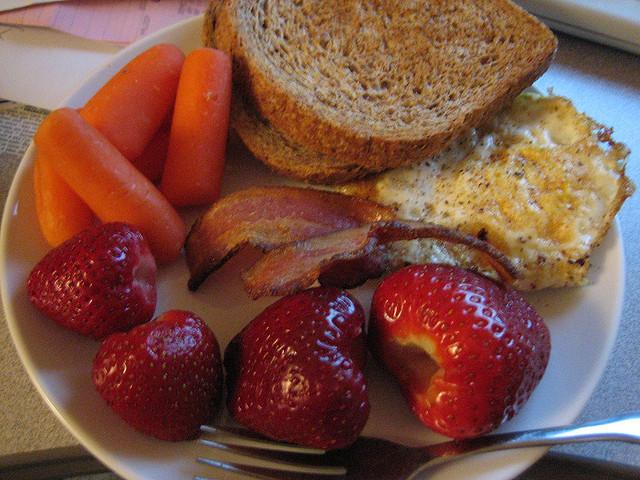What fruits are visible?
Give a very brief answer. Strawberries. How many bacon does it have on the plate?
Write a very short answer. 2. Is this a healthy breakfast?
Answer briefly. Yes. What meat is in the middle of the plate?
Short answer required. Bacon. What is the burgundy colored food on the plate?
Short answer required. Strawberry. What fruit is on the plate?
Write a very short answer. Strawberry. What is the red stuff on the plate?
Be succinct. Strawberries. 